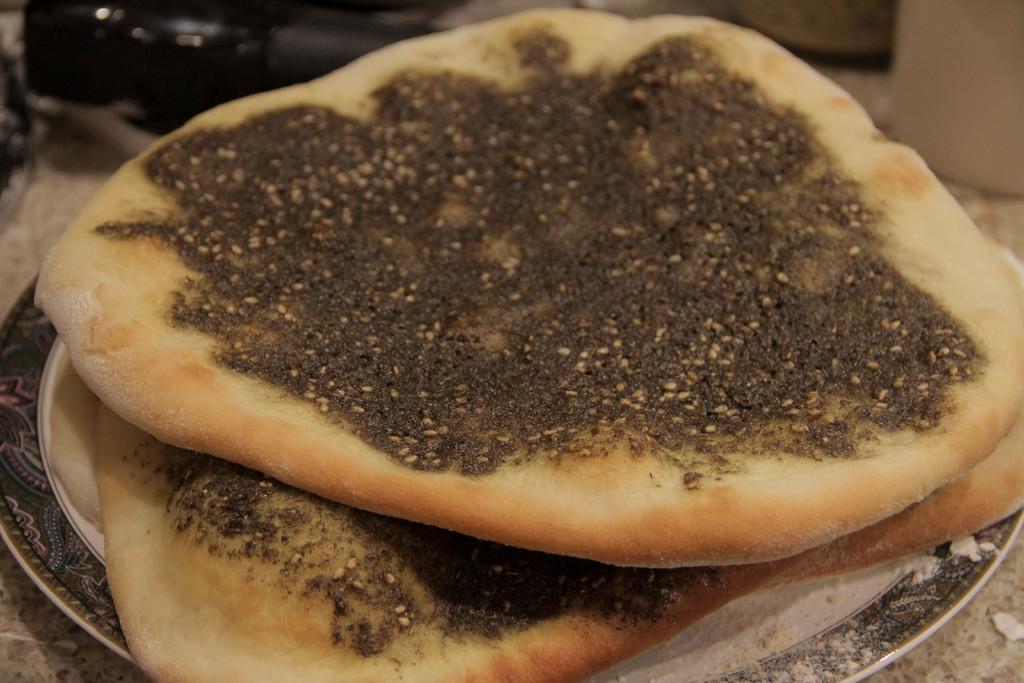Could you give a brief overview of what you see in this image? In this image I can see a plate which is white and black in color and on the plate I can see few pieces of food items which are brown, cream and black in color. In the background I can see few other objects which are black and cream in color. 